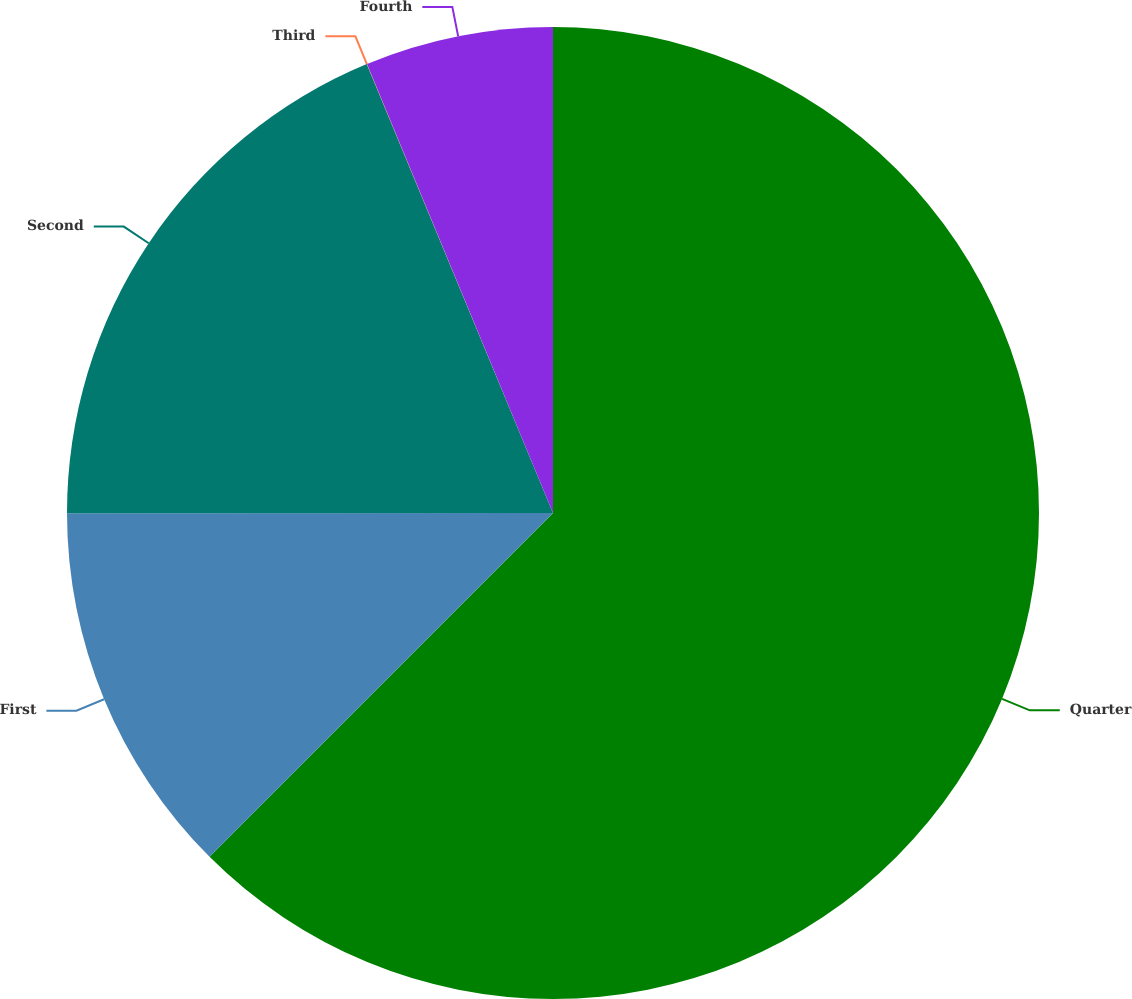<chart> <loc_0><loc_0><loc_500><loc_500><pie_chart><fcel>Quarter<fcel>First<fcel>Second<fcel>Third<fcel>Fourth<nl><fcel>62.49%<fcel>12.5%<fcel>18.75%<fcel>0.01%<fcel>6.25%<nl></chart> 